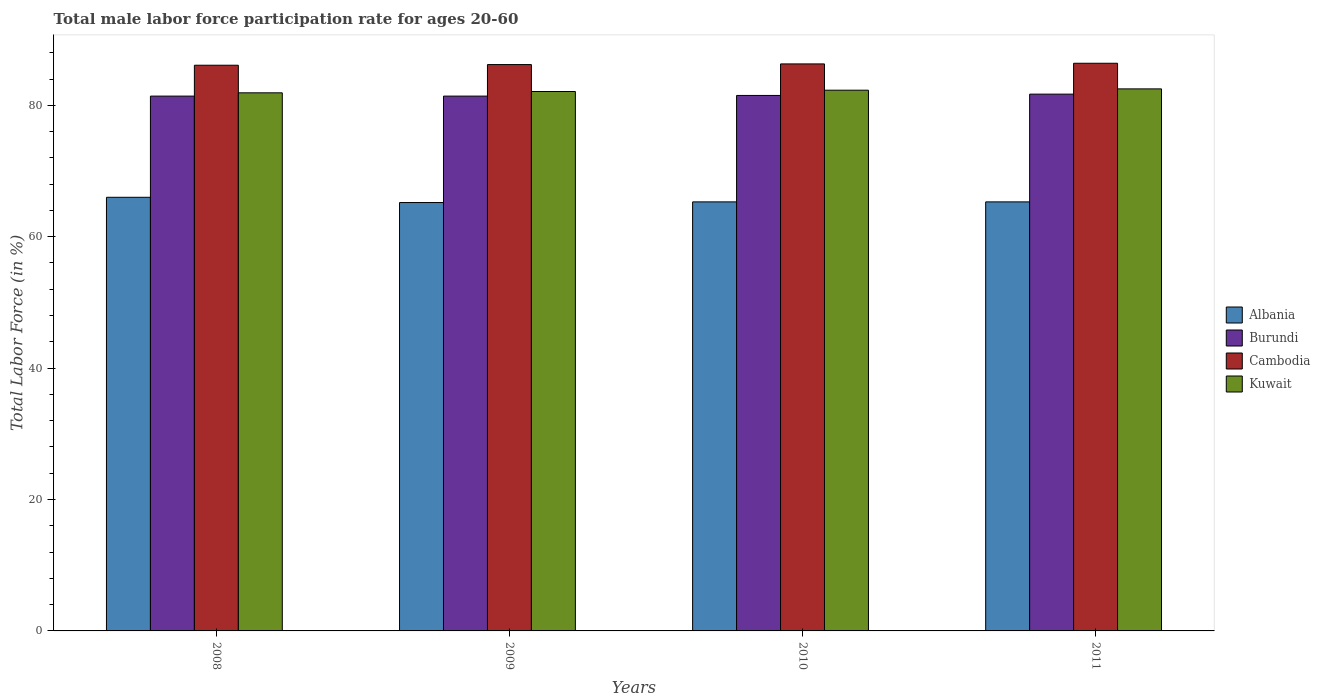How many different coloured bars are there?
Keep it short and to the point. 4. How many bars are there on the 1st tick from the right?
Offer a terse response. 4. What is the label of the 4th group of bars from the left?
Make the answer very short. 2011. What is the male labor force participation rate in Cambodia in 2011?
Ensure brevity in your answer.  86.4. Across all years, what is the maximum male labor force participation rate in Kuwait?
Your answer should be compact. 82.5. Across all years, what is the minimum male labor force participation rate in Burundi?
Offer a terse response. 81.4. What is the total male labor force participation rate in Albania in the graph?
Ensure brevity in your answer.  261.8. What is the difference between the male labor force participation rate in Albania in 2009 and that in 2010?
Provide a succinct answer. -0.1. What is the difference between the male labor force participation rate in Burundi in 2010 and the male labor force participation rate in Albania in 2009?
Your response must be concise. 16.3. What is the average male labor force participation rate in Kuwait per year?
Your answer should be compact. 82.2. In the year 2008, what is the difference between the male labor force participation rate in Kuwait and male labor force participation rate in Cambodia?
Your response must be concise. -4.2. What is the ratio of the male labor force participation rate in Cambodia in 2008 to that in 2009?
Your answer should be very brief. 1. Is the male labor force participation rate in Cambodia in 2008 less than that in 2009?
Offer a very short reply. Yes. What is the difference between the highest and the second highest male labor force participation rate in Cambodia?
Offer a terse response. 0.1. What is the difference between the highest and the lowest male labor force participation rate in Albania?
Your answer should be very brief. 0.8. In how many years, is the male labor force participation rate in Albania greater than the average male labor force participation rate in Albania taken over all years?
Provide a succinct answer. 1. Is the sum of the male labor force participation rate in Albania in 2009 and 2010 greater than the maximum male labor force participation rate in Cambodia across all years?
Give a very brief answer. Yes. What does the 4th bar from the left in 2010 represents?
Your answer should be very brief. Kuwait. What does the 4th bar from the right in 2011 represents?
Provide a succinct answer. Albania. Is it the case that in every year, the sum of the male labor force participation rate in Burundi and male labor force participation rate in Kuwait is greater than the male labor force participation rate in Cambodia?
Give a very brief answer. Yes. Are all the bars in the graph horizontal?
Make the answer very short. No. How many years are there in the graph?
Provide a short and direct response. 4. Where does the legend appear in the graph?
Your answer should be very brief. Center right. How are the legend labels stacked?
Your answer should be very brief. Vertical. What is the title of the graph?
Make the answer very short. Total male labor force participation rate for ages 20-60. What is the label or title of the Y-axis?
Your answer should be very brief. Total Labor Force (in %). What is the Total Labor Force (in %) of Burundi in 2008?
Ensure brevity in your answer.  81.4. What is the Total Labor Force (in %) in Cambodia in 2008?
Make the answer very short. 86.1. What is the Total Labor Force (in %) of Kuwait in 2008?
Your response must be concise. 81.9. What is the Total Labor Force (in %) in Albania in 2009?
Keep it short and to the point. 65.2. What is the Total Labor Force (in %) of Burundi in 2009?
Your answer should be compact. 81.4. What is the Total Labor Force (in %) of Cambodia in 2009?
Keep it short and to the point. 86.2. What is the Total Labor Force (in %) in Kuwait in 2009?
Ensure brevity in your answer.  82.1. What is the Total Labor Force (in %) of Albania in 2010?
Ensure brevity in your answer.  65.3. What is the Total Labor Force (in %) of Burundi in 2010?
Your response must be concise. 81.5. What is the Total Labor Force (in %) in Cambodia in 2010?
Ensure brevity in your answer.  86.3. What is the Total Labor Force (in %) in Kuwait in 2010?
Keep it short and to the point. 82.3. What is the Total Labor Force (in %) of Albania in 2011?
Make the answer very short. 65.3. What is the Total Labor Force (in %) in Burundi in 2011?
Ensure brevity in your answer.  81.7. What is the Total Labor Force (in %) of Cambodia in 2011?
Offer a very short reply. 86.4. What is the Total Labor Force (in %) in Kuwait in 2011?
Offer a very short reply. 82.5. Across all years, what is the maximum Total Labor Force (in %) of Albania?
Provide a short and direct response. 66. Across all years, what is the maximum Total Labor Force (in %) in Burundi?
Provide a short and direct response. 81.7. Across all years, what is the maximum Total Labor Force (in %) of Cambodia?
Offer a terse response. 86.4. Across all years, what is the maximum Total Labor Force (in %) of Kuwait?
Keep it short and to the point. 82.5. Across all years, what is the minimum Total Labor Force (in %) of Albania?
Offer a very short reply. 65.2. Across all years, what is the minimum Total Labor Force (in %) in Burundi?
Your response must be concise. 81.4. Across all years, what is the minimum Total Labor Force (in %) in Cambodia?
Provide a short and direct response. 86.1. Across all years, what is the minimum Total Labor Force (in %) in Kuwait?
Give a very brief answer. 81.9. What is the total Total Labor Force (in %) of Albania in the graph?
Your answer should be very brief. 261.8. What is the total Total Labor Force (in %) in Burundi in the graph?
Your answer should be compact. 326. What is the total Total Labor Force (in %) in Cambodia in the graph?
Offer a very short reply. 345. What is the total Total Labor Force (in %) of Kuwait in the graph?
Ensure brevity in your answer.  328.8. What is the difference between the Total Labor Force (in %) in Burundi in 2008 and that in 2009?
Make the answer very short. 0. What is the difference between the Total Labor Force (in %) of Kuwait in 2008 and that in 2009?
Provide a succinct answer. -0.2. What is the difference between the Total Labor Force (in %) of Albania in 2008 and that in 2010?
Your answer should be compact. 0.7. What is the difference between the Total Labor Force (in %) of Burundi in 2008 and that in 2010?
Offer a very short reply. -0.1. What is the difference between the Total Labor Force (in %) of Cambodia in 2008 and that in 2010?
Provide a short and direct response. -0.2. What is the difference between the Total Labor Force (in %) in Kuwait in 2008 and that in 2010?
Keep it short and to the point. -0.4. What is the difference between the Total Labor Force (in %) in Albania in 2008 and that in 2011?
Ensure brevity in your answer.  0.7. What is the difference between the Total Labor Force (in %) of Burundi in 2008 and that in 2011?
Make the answer very short. -0.3. What is the difference between the Total Labor Force (in %) of Cambodia in 2008 and that in 2011?
Your response must be concise. -0.3. What is the difference between the Total Labor Force (in %) in Kuwait in 2008 and that in 2011?
Provide a short and direct response. -0.6. What is the difference between the Total Labor Force (in %) in Burundi in 2009 and that in 2010?
Keep it short and to the point. -0.1. What is the difference between the Total Labor Force (in %) in Cambodia in 2009 and that in 2011?
Provide a short and direct response. -0.2. What is the difference between the Total Labor Force (in %) in Kuwait in 2009 and that in 2011?
Keep it short and to the point. -0.4. What is the difference between the Total Labor Force (in %) of Cambodia in 2010 and that in 2011?
Ensure brevity in your answer.  -0.1. What is the difference between the Total Labor Force (in %) in Albania in 2008 and the Total Labor Force (in %) in Burundi in 2009?
Ensure brevity in your answer.  -15.4. What is the difference between the Total Labor Force (in %) of Albania in 2008 and the Total Labor Force (in %) of Cambodia in 2009?
Your answer should be very brief. -20.2. What is the difference between the Total Labor Force (in %) in Albania in 2008 and the Total Labor Force (in %) in Kuwait in 2009?
Offer a terse response. -16.1. What is the difference between the Total Labor Force (in %) of Burundi in 2008 and the Total Labor Force (in %) of Cambodia in 2009?
Ensure brevity in your answer.  -4.8. What is the difference between the Total Labor Force (in %) in Cambodia in 2008 and the Total Labor Force (in %) in Kuwait in 2009?
Give a very brief answer. 4. What is the difference between the Total Labor Force (in %) of Albania in 2008 and the Total Labor Force (in %) of Burundi in 2010?
Give a very brief answer. -15.5. What is the difference between the Total Labor Force (in %) of Albania in 2008 and the Total Labor Force (in %) of Cambodia in 2010?
Your answer should be compact. -20.3. What is the difference between the Total Labor Force (in %) in Albania in 2008 and the Total Labor Force (in %) in Kuwait in 2010?
Offer a very short reply. -16.3. What is the difference between the Total Labor Force (in %) of Burundi in 2008 and the Total Labor Force (in %) of Cambodia in 2010?
Keep it short and to the point. -4.9. What is the difference between the Total Labor Force (in %) in Albania in 2008 and the Total Labor Force (in %) in Burundi in 2011?
Provide a succinct answer. -15.7. What is the difference between the Total Labor Force (in %) in Albania in 2008 and the Total Labor Force (in %) in Cambodia in 2011?
Provide a short and direct response. -20.4. What is the difference between the Total Labor Force (in %) of Albania in 2008 and the Total Labor Force (in %) of Kuwait in 2011?
Your answer should be compact. -16.5. What is the difference between the Total Labor Force (in %) of Cambodia in 2008 and the Total Labor Force (in %) of Kuwait in 2011?
Keep it short and to the point. 3.6. What is the difference between the Total Labor Force (in %) in Albania in 2009 and the Total Labor Force (in %) in Burundi in 2010?
Your response must be concise. -16.3. What is the difference between the Total Labor Force (in %) of Albania in 2009 and the Total Labor Force (in %) of Cambodia in 2010?
Your answer should be compact. -21.1. What is the difference between the Total Labor Force (in %) in Albania in 2009 and the Total Labor Force (in %) in Kuwait in 2010?
Provide a short and direct response. -17.1. What is the difference between the Total Labor Force (in %) in Burundi in 2009 and the Total Labor Force (in %) in Kuwait in 2010?
Provide a short and direct response. -0.9. What is the difference between the Total Labor Force (in %) of Albania in 2009 and the Total Labor Force (in %) of Burundi in 2011?
Offer a very short reply. -16.5. What is the difference between the Total Labor Force (in %) of Albania in 2009 and the Total Labor Force (in %) of Cambodia in 2011?
Provide a short and direct response. -21.2. What is the difference between the Total Labor Force (in %) of Albania in 2009 and the Total Labor Force (in %) of Kuwait in 2011?
Ensure brevity in your answer.  -17.3. What is the difference between the Total Labor Force (in %) of Albania in 2010 and the Total Labor Force (in %) of Burundi in 2011?
Offer a very short reply. -16.4. What is the difference between the Total Labor Force (in %) of Albania in 2010 and the Total Labor Force (in %) of Cambodia in 2011?
Ensure brevity in your answer.  -21.1. What is the difference between the Total Labor Force (in %) of Albania in 2010 and the Total Labor Force (in %) of Kuwait in 2011?
Offer a terse response. -17.2. What is the average Total Labor Force (in %) of Albania per year?
Ensure brevity in your answer.  65.45. What is the average Total Labor Force (in %) of Burundi per year?
Ensure brevity in your answer.  81.5. What is the average Total Labor Force (in %) in Cambodia per year?
Ensure brevity in your answer.  86.25. What is the average Total Labor Force (in %) in Kuwait per year?
Ensure brevity in your answer.  82.2. In the year 2008, what is the difference between the Total Labor Force (in %) of Albania and Total Labor Force (in %) of Burundi?
Ensure brevity in your answer.  -15.4. In the year 2008, what is the difference between the Total Labor Force (in %) of Albania and Total Labor Force (in %) of Cambodia?
Make the answer very short. -20.1. In the year 2008, what is the difference between the Total Labor Force (in %) of Albania and Total Labor Force (in %) of Kuwait?
Give a very brief answer. -15.9. In the year 2008, what is the difference between the Total Labor Force (in %) in Cambodia and Total Labor Force (in %) in Kuwait?
Offer a very short reply. 4.2. In the year 2009, what is the difference between the Total Labor Force (in %) in Albania and Total Labor Force (in %) in Burundi?
Provide a succinct answer. -16.2. In the year 2009, what is the difference between the Total Labor Force (in %) of Albania and Total Labor Force (in %) of Kuwait?
Keep it short and to the point. -16.9. In the year 2009, what is the difference between the Total Labor Force (in %) in Burundi and Total Labor Force (in %) in Cambodia?
Ensure brevity in your answer.  -4.8. In the year 2009, what is the difference between the Total Labor Force (in %) in Burundi and Total Labor Force (in %) in Kuwait?
Provide a short and direct response. -0.7. In the year 2010, what is the difference between the Total Labor Force (in %) in Albania and Total Labor Force (in %) in Burundi?
Provide a short and direct response. -16.2. In the year 2010, what is the difference between the Total Labor Force (in %) in Albania and Total Labor Force (in %) in Kuwait?
Give a very brief answer. -17. In the year 2010, what is the difference between the Total Labor Force (in %) of Burundi and Total Labor Force (in %) of Cambodia?
Make the answer very short. -4.8. In the year 2010, what is the difference between the Total Labor Force (in %) in Burundi and Total Labor Force (in %) in Kuwait?
Provide a short and direct response. -0.8. In the year 2010, what is the difference between the Total Labor Force (in %) in Cambodia and Total Labor Force (in %) in Kuwait?
Offer a terse response. 4. In the year 2011, what is the difference between the Total Labor Force (in %) in Albania and Total Labor Force (in %) in Burundi?
Provide a succinct answer. -16.4. In the year 2011, what is the difference between the Total Labor Force (in %) of Albania and Total Labor Force (in %) of Cambodia?
Your answer should be very brief. -21.1. In the year 2011, what is the difference between the Total Labor Force (in %) in Albania and Total Labor Force (in %) in Kuwait?
Make the answer very short. -17.2. In the year 2011, what is the difference between the Total Labor Force (in %) of Burundi and Total Labor Force (in %) of Cambodia?
Your response must be concise. -4.7. In the year 2011, what is the difference between the Total Labor Force (in %) of Burundi and Total Labor Force (in %) of Kuwait?
Your answer should be very brief. -0.8. What is the ratio of the Total Labor Force (in %) of Albania in 2008 to that in 2009?
Give a very brief answer. 1.01. What is the ratio of the Total Labor Force (in %) of Cambodia in 2008 to that in 2009?
Offer a very short reply. 1. What is the ratio of the Total Labor Force (in %) in Albania in 2008 to that in 2010?
Your answer should be very brief. 1.01. What is the ratio of the Total Labor Force (in %) in Cambodia in 2008 to that in 2010?
Your response must be concise. 1. What is the ratio of the Total Labor Force (in %) of Kuwait in 2008 to that in 2010?
Your answer should be compact. 1. What is the ratio of the Total Labor Force (in %) of Albania in 2008 to that in 2011?
Ensure brevity in your answer.  1.01. What is the ratio of the Total Labor Force (in %) of Burundi in 2008 to that in 2011?
Your answer should be very brief. 1. What is the ratio of the Total Labor Force (in %) of Burundi in 2009 to that in 2010?
Your answer should be very brief. 1. What is the ratio of the Total Labor Force (in %) in Kuwait in 2009 to that in 2010?
Provide a short and direct response. 1. What is the ratio of the Total Labor Force (in %) of Cambodia in 2009 to that in 2011?
Your response must be concise. 1. What is the ratio of the Total Labor Force (in %) in Albania in 2010 to that in 2011?
Give a very brief answer. 1. What is the ratio of the Total Labor Force (in %) of Burundi in 2010 to that in 2011?
Provide a succinct answer. 1. What is the ratio of the Total Labor Force (in %) of Kuwait in 2010 to that in 2011?
Your answer should be compact. 1. What is the difference between the highest and the second highest Total Labor Force (in %) of Kuwait?
Make the answer very short. 0.2. What is the difference between the highest and the lowest Total Labor Force (in %) of Albania?
Offer a terse response. 0.8. What is the difference between the highest and the lowest Total Labor Force (in %) of Burundi?
Offer a terse response. 0.3. What is the difference between the highest and the lowest Total Labor Force (in %) in Cambodia?
Provide a short and direct response. 0.3. 